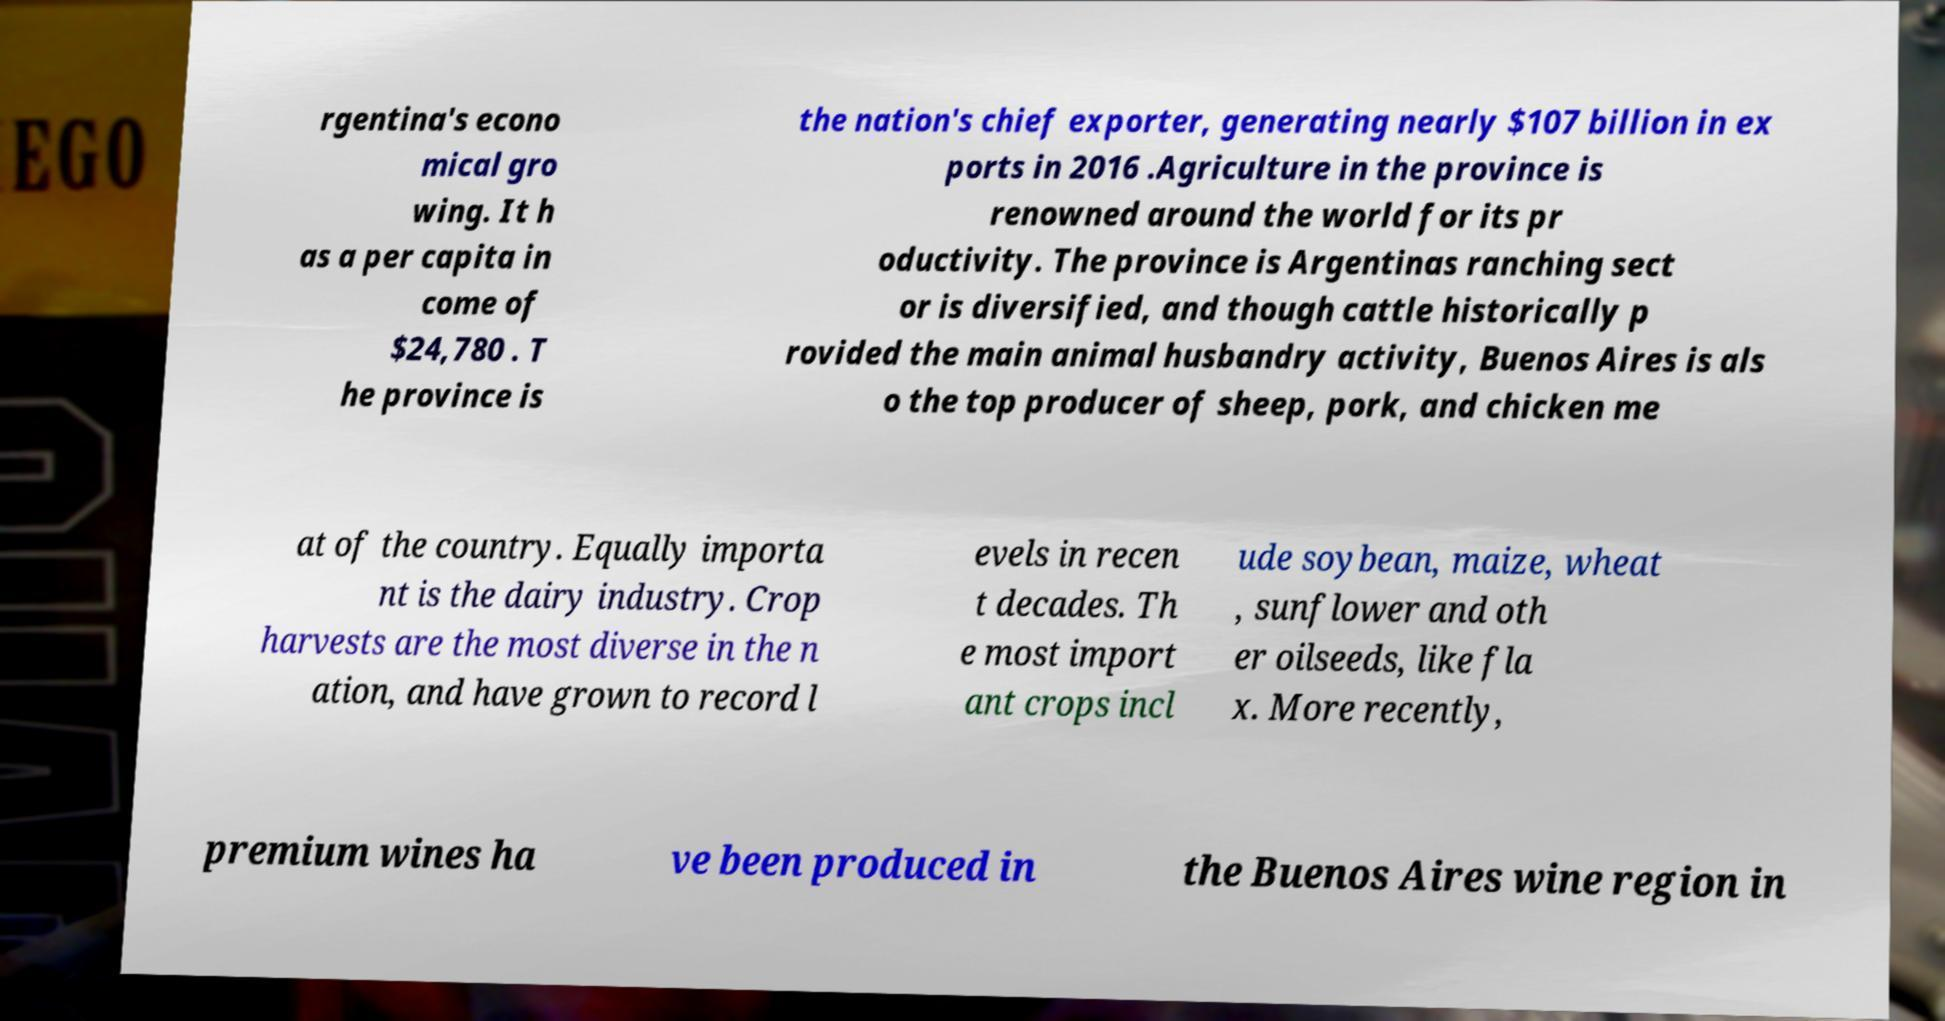There's text embedded in this image that I need extracted. Can you transcribe it verbatim? rgentina's econo mical gro wing. It h as a per capita in come of $24,780 . T he province is the nation's chief exporter, generating nearly $107 billion in ex ports in 2016 .Agriculture in the province is renowned around the world for its pr oductivity. The province is Argentinas ranching sect or is diversified, and though cattle historically p rovided the main animal husbandry activity, Buenos Aires is als o the top producer of sheep, pork, and chicken me at of the country. Equally importa nt is the dairy industry. Crop harvests are the most diverse in the n ation, and have grown to record l evels in recen t decades. Th e most import ant crops incl ude soybean, maize, wheat , sunflower and oth er oilseeds, like fla x. More recently, premium wines ha ve been produced in the Buenos Aires wine region in 